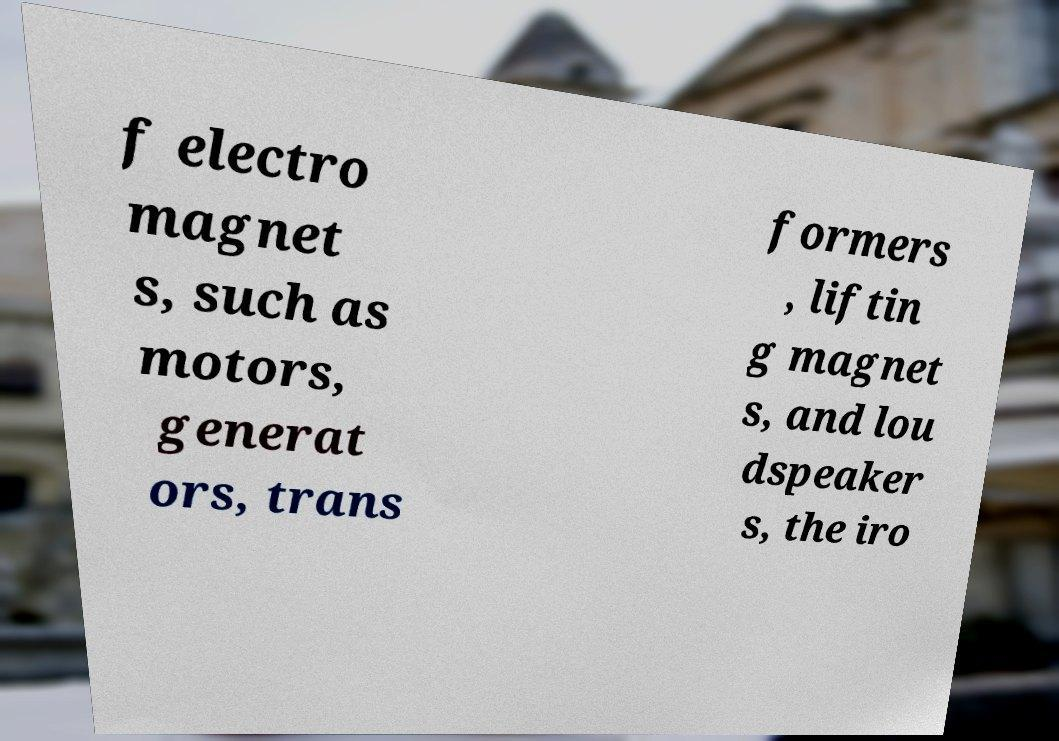For documentation purposes, I need the text within this image transcribed. Could you provide that? f electro magnet s, such as motors, generat ors, trans formers , liftin g magnet s, and lou dspeaker s, the iro 